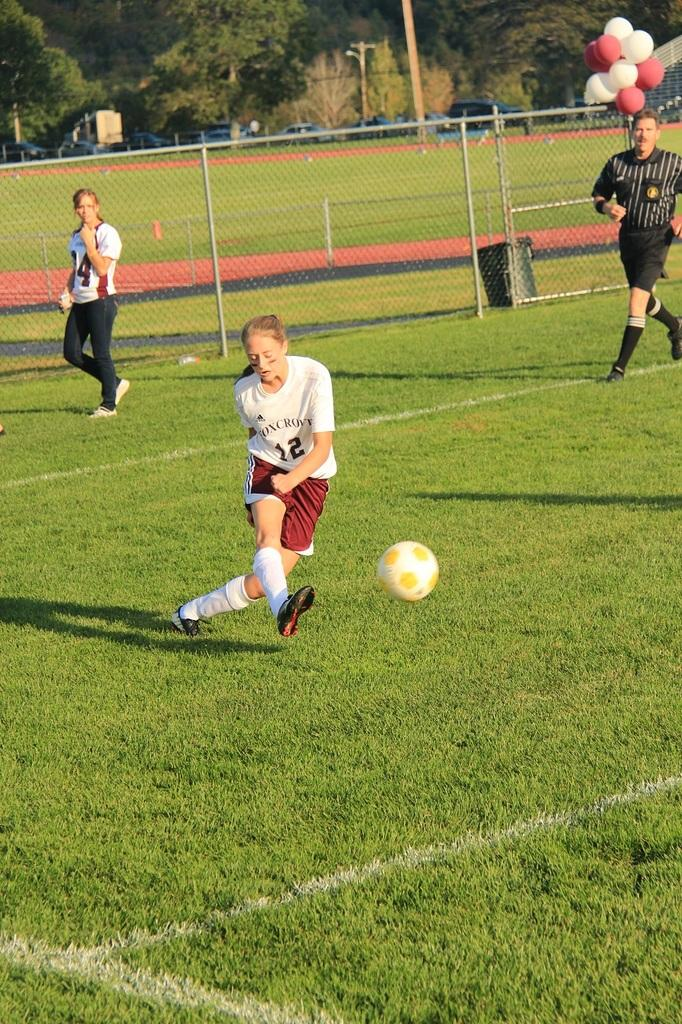<image>
Offer a succinct explanation of the picture presented. A female soccer player with the number 12 on the front of her shirt, is about to kick the soccer ball across the field. 